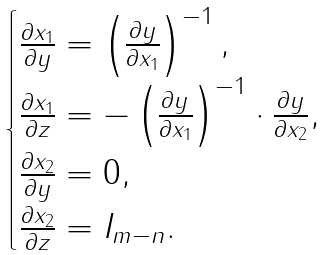Convert formula to latex. <formula><loc_0><loc_0><loc_500><loc_500>\begin{cases} \frac { \partial x _ { 1 } } { \partial y } = \left ( \frac { \partial y } { \partial x _ { 1 } } \right ) ^ { - 1 } , \\ \frac { \partial x _ { 1 } } { \partial z } = - \left ( \frac { \partial y } { \partial x _ { 1 } } \right ) ^ { - 1 } \cdot \frac { \partial y } { \partial x _ { 2 } } , \\ \frac { \partial x _ { 2 } } { \partial y } = 0 , \\ \frac { \partial x _ { 2 } } { \partial z } = I _ { m - n } . \end{cases}</formula> 